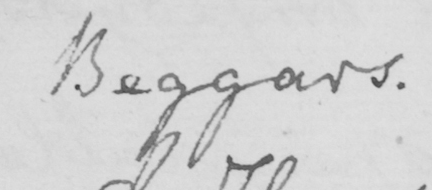Please transcribe the handwritten text in this image. Beggars . 